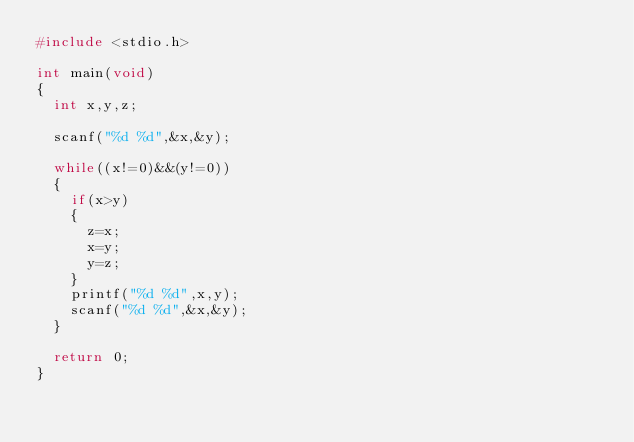<code> <loc_0><loc_0><loc_500><loc_500><_C_>#include <stdio.h> 

int main(void)
{
	int x,y,z;

	scanf("%d %d",&x,&y);

	while((x!=0)&&(y!=0))
	{
		if(x>y)
		{
			z=x;
			x=y;
			y=z;
		}
		printf("%d %d",x,y);
		scanf("%d %d",&x,&y);
	}

	return 0;
}</code> 